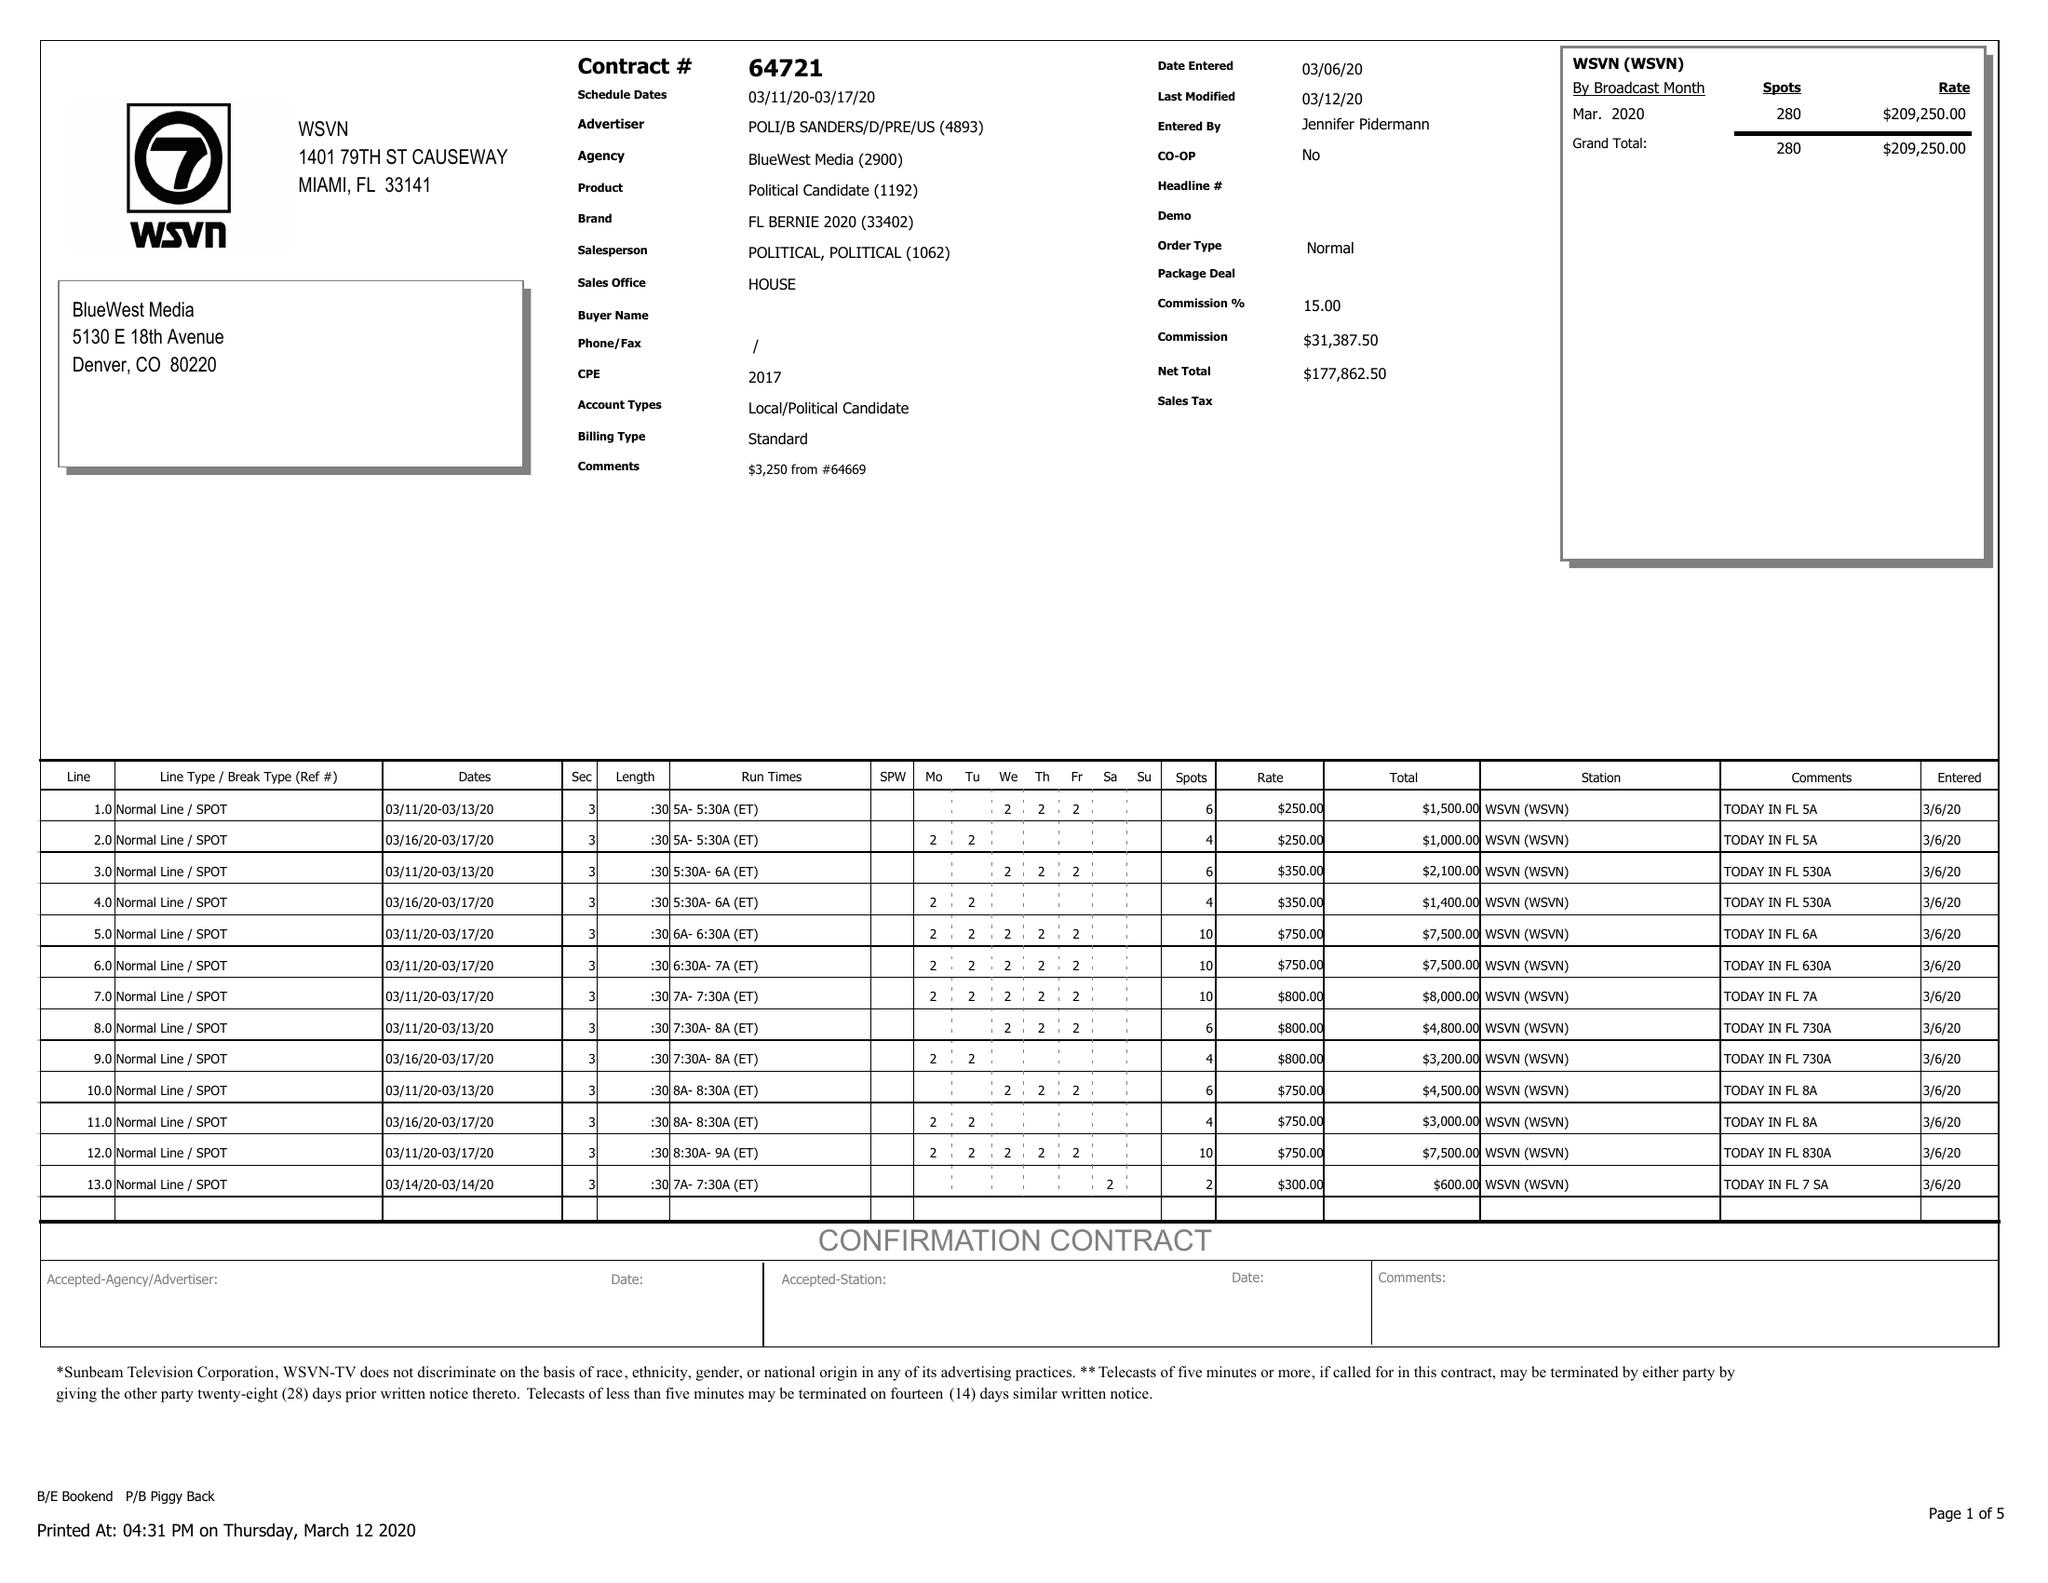What is the value for the contract_num?
Answer the question using a single word or phrase. 64721 